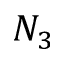Convert formula to latex. <formula><loc_0><loc_0><loc_500><loc_500>N _ { 3 }</formula> 